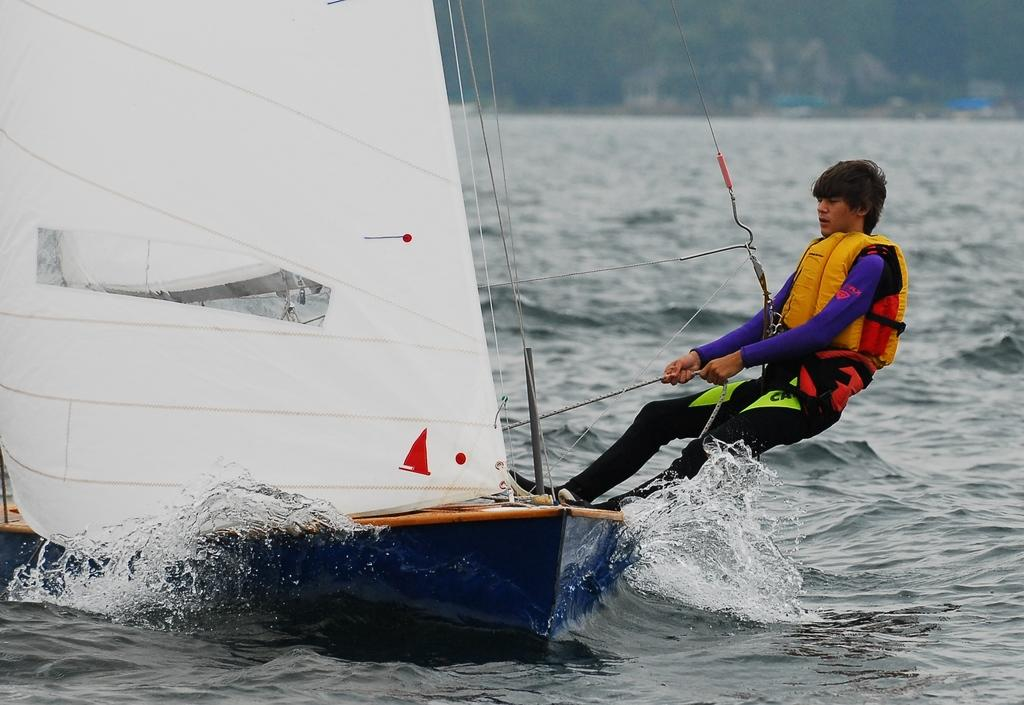What type of vehicle is in the image? There is a watercraft in the image. What natural feature is visible in the background? The sea is visible in the image. Can you describe the person in the image? There is a person in the image. What type of vegetation is at the top of the image? There are trees at the top of the image. What type of poison is being used by the snail in the image? There is no snail or poison present in the image. 